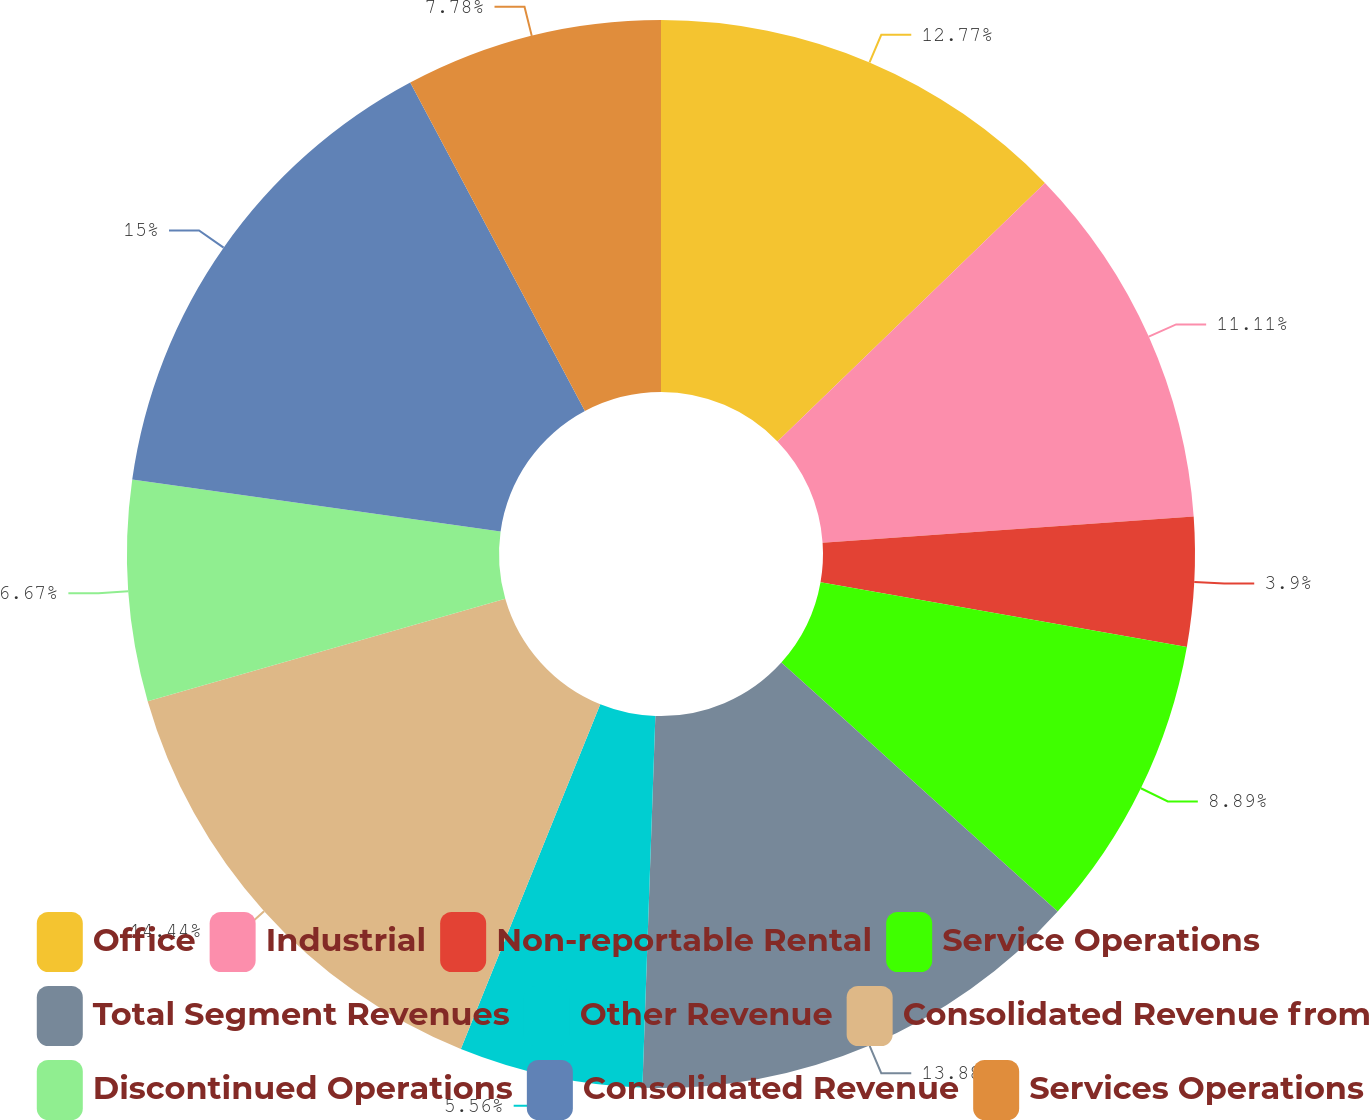Convert chart to OTSL. <chart><loc_0><loc_0><loc_500><loc_500><pie_chart><fcel>Office<fcel>Industrial<fcel>Non-reportable Rental<fcel>Service Operations<fcel>Total Segment Revenues<fcel>Other Revenue<fcel>Consolidated Revenue from<fcel>Discontinued Operations<fcel>Consolidated Revenue<fcel>Services Operations<nl><fcel>12.77%<fcel>11.11%<fcel>3.9%<fcel>8.89%<fcel>13.88%<fcel>5.56%<fcel>14.44%<fcel>6.67%<fcel>14.99%<fcel>7.78%<nl></chart> 